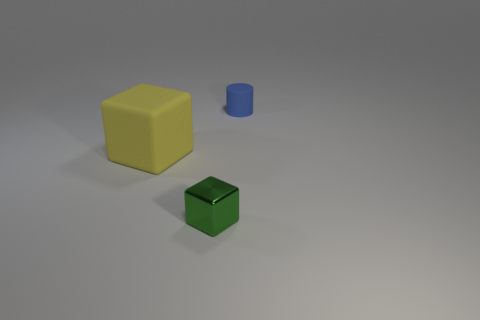Add 2 small gray matte objects. How many objects exist? 5 Subtract all blocks. How many objects are left? 1 Add 1 large rubber objects. How many large rubber objects are left? 2 Add 3 purple spheres. How many purple spheres exist? 3 Subtract 0 yellow spheres. How many objects are left? 3 Subtract all big yellow matte cubes. Subtract all tiny green cubes. How many objects are left? 1 